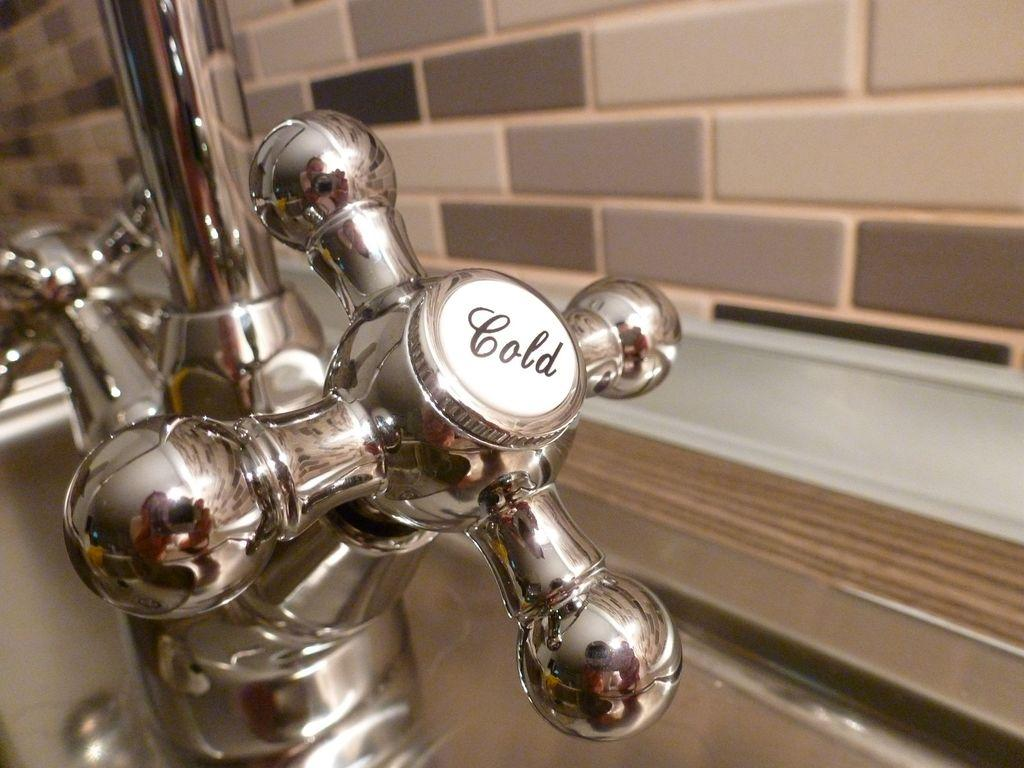What object is located on the left side of the image? There is a tap on the left side of the image. What can be seen on the tap? There is text visible on the tap. What is behind the tap in the image? There is a mirror behind the tap. What is on the right side of the image? There is a wall on the right side of the image. Where is the map located in the image? There is no map present in the image. What type of beast can be seen lurking behind the wall in the image? There is no beast present in the image; it only features a tap, text, a mirror, and a wall. 